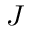Convert formula to latex. <formula><loc_0><loc_0><loc_500><loc_500>J</formula> 